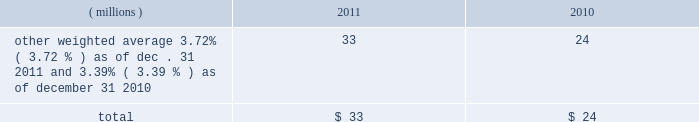Notes to the consolidated financial statements at a price equal to 101% ( 101 % ) of their principal amount plus accrued and unpaid interest .
Cash proceeds from the sale of these notes was $ 983 million ( net of discount and issuance costs ) .
The discount and issuance costs related to these notes , which totaled $ 17 million , will be amortized to interest expense over the respective terms of the notes .
In august 2010 , ppg entered into a three-year credit agreement with several banks and financial institutions ( the 201ccredit agreement 201d ) .
The credit agreement provides for a $ 1.2 billion unsecured revolving credit facility .
In connection with entering into this credit agreement , the company terminated its 20ac650 million and its $ 1 billion revolving credit facilities that were each set to expire in 2011 .
There were no outstanding amounts due under either revolving facility at the times of their termination .
The company has the ability to increase the size of the credit agreement by up to an additional $ 300 million , subject to the receipt of lender commitments and other conditions .
The credit agreement will terminate and all amounts outstanding will be due and payable on august 5 , 2013 .
The credit agreement provides that loans will bear interest at rates based , at the company 2019s option , on one of two specified base rates plus a margin based on certain formulas defined in the credit agreement .
Additionally , the credit agreement contains a commitment fee on the amount of unused commitment under the credit agreement ranging from 0.125% ( 0.125 % ) to 0.625% ( 0.625 % ) per annum .
The applicable interest rate and the fee will vary depending on the ratings established by standard & poor 2019s financial services llc and moody 2019s investor service inc .
For the company 2019s non-credit enhanced , long- term , senior , unsecured debt .
There were no amounts outstanding under the credit agreement at december 31 , 2011 ; however , the available borrowing rate on a one month , u.s .
Dollar denominated borrowing would have been 1.05 percent .
The credit agreement contains usual and customary restrictive covenants for facilities of its type , which include , with specified exceptions , limitations on the company 2019s ability to create liens or other encumbrances , to enter into sale and leaseback transactions and to enter into consolidations , mergers or transfers of all or substantially all of its assets .
The credit agreement also requires the company to maintain a ratio of total indebtedness to total capitalization , as defined in the credit agreement , of 60 percent or less .
The credit agreement contains customary events of default that would permit the lenders to accelerate the repayment of any loans , including the failure to make timely payments when due under the credit agreement or other material indebtedness , the failure to satisfy covenants contained in the credit agreement , a change in control of the company and specified events of bankruptcy and insolvency .
Ppg 2019s non-u.s .
Operations have uncommitted lines of credit totaling $ 679 million of which $ 36 million was used as of december 31 , 2011 .
These uncommitted lines of credit are subject to cancellation at any time and are generally not subject to any commitment fees .
Short-term debt outstanding as of december 31 , 2011 and 2010 , was as follows : ( millions ) 2011 2010 other , weighted average 3.72% ( 3.72 % ) as of dec .
31 , 2011 and 3.39% ( 3.39 % ) as of december 31 , 2010 33 24 total $ 33 $ 24 ppg is in compliance with the restrictive covenants under its various credit agreements , loan agreements and indentures .
The company 2019s revolving credit agreements include a financial ratio covenant .
The covenant requires that the amount of total indebtedness not exceed 60% ( 60 % ) of the company 2019s total capitalization excluding the portion of accumulated other comprehensive income ( loss ) related to pensions and other postretirement benefit adjustments .
As of december 31 , 2011 , total indebtedness was 43 percent of the company 2019s total capitalization excluding the portion of accumulated other comprehensive income ( loss ) related to pensions and other postretirement benefit adjustments .
Additionally , substantially all of the company 2019s debt agreements contain customary cross-default provisions .
Those provisions generally provide that a default on a debt service payment of $ 10 million or more for longer than the grace period provided ( usually 10 days ) under one agreement may result in an event of default under other agreements .
None of the company 2019s primary debt obligations are secured or guaranteed by the company 2019s affiliates .
Interest payments in 2011 , 2010 and 2009 totaled $ 212 million , $ 189 million and $ 201 million , respectively .
In october 2009 , the company entered into an agreement with a counterparty to repurchase up to 1.2 million shares of the company 2019s stock of which 1.1 million shares were purchased in the open market ( 465006 of these shares were purchased as of december 31 , 2009 at a weighted average price of $ 56.66 per share ) .
The counterparty held the shares until september of 2010 when the company paid $ 65 million and took possession of these shares .
In december 2008 , the company entered into an agreement with a counterparty to repurchase 1.5 million 44 2011 ppg annual report and form 10-k .
Notes to the consolidated financial statements at a price equal to 101% ( 101 % ) of their principal amount plus accrued and unpaid interest .
Cash proceeds from the sale of these notes was $ 983 million ( net of discount and issuance costs ) .
The discount and issuance costs related to these notes , which totaled $ 17 million , will be amortized to interest expense over the respective terms of the notes .
In august 2010 , ppg entered into a three-year credit agreement with several banks and financial institutions ( the 201ccredit agreement 201d ) .
The credit agreement provides for a $ 1.2 billion unsecured revolving credit facility .
In connection with entering into this credit agreement , the company terminated its 20ac650 million and its $ 1 billion revolving credit facilities that were each set to expire in 2011 .
There were no outstanding amounts due under either revolving facility at the times of their termination .
The company has the ability to increase the size of the credit agreement by up to an additional $ 300 million , subject to the receipt of lender commitments and other conditions .
The credit agreement will terminate and all amounts outstanding will be due and payable on august 5 , 2013 .
The credit agreement provides that loans will bear interest at rates based , at the company 2019s option , on one of two specified base rates plus a margin based on certain formulas defined in the credit agreement .
Additionally , the credit agreement contains a commitment fee on the amount of unused commitment under the credit agreement ranging from 0.125% ( 0.125 % ) to 0.625% ( 0.625 % ) per annum .
The applicable interest rate and the fee will vary depending on the ratings established by standard & poor 2019s financial services llc and moody 2019s investor service inc .
For the company 2019s non-credit enhanced , long- term , senior , unsecured debt .
There were no amounts outstanding under the credit agreement at december 31 , 2011 ; however , the available borrowing rate on a one month , u.s .
Dollar denominated borrowing would have been 1.05 percent .
The credit agreement contains usual and customary restrictive covenants for facilities of its type , which include , with specified exceptions , limitations on the company 2019s ability to create liens or other encumbrances , to enter into sale and leaseback transactions and to enter into consolidations , mergers or transfers of all or substantially all of its assets .
The credit agreement also requires the company to maintain a ratio of total indebtedness to total capitalization , as defined in the credit agreement , of 60 percent or less .
The credit agreement contains customary events of default that would permit the lenders to accelerate the repayment of any loans , including the failure to make timely payments when due under the credit agreement or other material indebtedness , the failure to satisfy covenants contained in the credit agreement , a change in control of the company and specified events of bankruptcy and insolvency .
Ppg 2019s non-u.s .
Operations have uncommitted lines of credit totaling $ 679 million of which $ 36 million was used as of december 31 , 2011 .
These uncommitted lines of credit are subject to cancellation at any time and are generally not subject to any commitment fees .
Short-term debt outstanding as of december 31 , 2011 and 2010 , was as follows : ( millions ) 2011 2010 other , weighted average 3.72% ( 3.72 % ) as of dec .
31 , 2011 and 3.39% ( 3.39 % ) as of december 31 , 2010 33 24 total $ 33 $ 24 ppg is in compliance with the restrictive covenants under its various credit agreements , loan agreements and indentures .
The company 2019s revolving credit agreements include a financial ratio covenant .
The covenant requires that the amount of total indebtedness not exceed 60% ( 60 % ) of the company 2019s total capitalization excluding the portion of accumulated other comprehensive income ( loss ) related to pensions and other postretirement benefit adjustments .
As of december 31 , 2011 , total indebtedness was 43 percent of the company 2019s total capitalization excluding the portion of accumulated other comprehensive income ( loss ) related to pensions and other postretirement benefit adjustments .
Additionally , substantially all of the company 2019s debt agreements contain customary cross-default provisions .
Those provisions generally provide that a default on a debt service payment of $ 10 million or more for longer than the grace period provided ( usually 10 days ) under one agreement may result in an event of default under other agreements .
None of the company 2019s primary debt obligations are secured or guaranteed by the company 2019s affiliates .
Interest payments in 2011 , 2010 and 2009 totaled $ 212 million , $ 189 million and $ 201 million , respectively .
In october 2009 , the company entered into an agreement with a counterparty to repurchase up to 1.2 million shares of the company 2019s stock of which 1.1 million shares were purchased in the open market ( 465006 of these shares were purchased as of december 31 , 2009 at a weighted average price of $ 56.66 per share ) .
The counterparty held the shares until september of 2010 when the company paid $ 65 million and took possession of these shares .
In december 2008 , the company entered into an agreement with a counterparty to repurchase 1.5 million 44 2011 ppg annual report and form 10-k .
What would the remaining cost to repurchase shares under the october 2009 agreement be assuming the december 31 , 2009 weighted average share price ? 
Computations: (((1.2 - 1.1) * 1000000) * 56.66)
Answer: 5666000.0. 